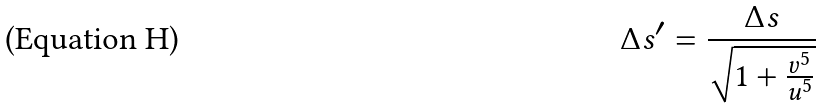Convert formula to latex. <formula><loc_0><loc_0><loc_500><loc_500>\Delta s ^ { \prime } = \frac { \Delta s } { \sqrt { 1 + \frac { v ^ { 5 } } { u ^ { 5 } } } }</formula> 